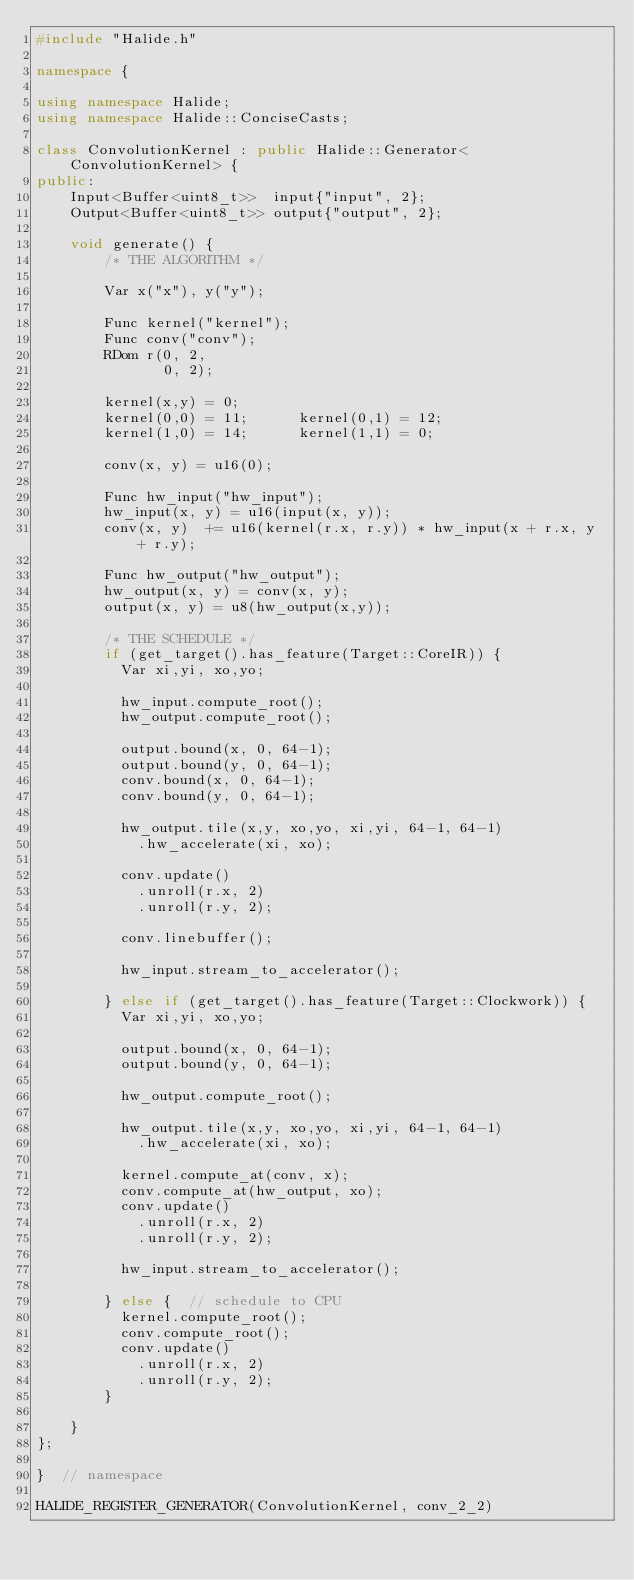<code> <loc_0><loc_0><loc_500><loc_500><_C++_>#include "Halide.h"

namespace {

using namespace Halide;
using namespace Halide::ConciseCasts;

class ConvolutionKernel : public Halide::Generator<ConvolutionKernel> {
public:
    Input<Buffer<uint8_t>>  input{"input", 2};
    Output<Buffer<uint8_t>> output{"output", 2};

    void generate() {
        /* THE ALGORITHM */

        Var x("x"), y("y");

        Func kernel("kernel");
        Func conv("conv");
        RDom r(0, 2,
               0, 2);

        kernel(x,y) = 0;
        kernel(0,0) = 11;      kernel(0,1) = 12;
        kernel(1,0) = 14;      kernel(1,1) = 0;

        conv(x, y) = u16(0);

        Func hw_input("hw_input");
        hw_input(x, y) = u16(input(x, y));
        conv(x, y)  += u16(kernel(r.x, r.y)) * hw_input(x + r.x, y + r.y);

        Func hw_output("hw_output");
        hw_output(x, y) = conv(x, y);
        output(x, y) = u8(hw_output(x,y));

        /* THE SCHEDULE */
        if (get_target().has_feature(Target::CoreIR)) {
          Var xi,yi, xo,yo;

          hw_input.compute_root();
          hw_output.compute_root();

          output.bound(x, 0, 64-1);
          output.bound(y, 0, 64-1);
          conv.bound(x, 0, 64-1);
          conv.bound(y, 0, 64-1);

          hw_output.tile(x,y, xo,yo, xi,yi, 64-1, 64-1)
            .hw_accelerate(xi, xo);

          conv.update()
            .unroll(r.x, 2)
            .unroll(r.y, 2);

          conv.linebuffer();

          hw_input.stream_to_accelerator();

        } else if (get_target().has_feature(Target::Clockwork)) {
          Var xi,yi, xo,yo;

          output.bound(x, 0, 64-1);
          output.bound(y, 0, 64-1);

          hw_output.compute_root();

          hw_output.tile(x,y, xo,yo, xi,yi, 64-1, 64-1)
            .hw_accelerate(xi, xo);

          kernel.compute_at(conv, x);
          conv.compute_at(hw_output, xo);
          conv.update()
            .unroll(r.x, 2)
            .unroll(r.y, 2);

          hw_input.stream_to_accelerator();

        } else {  // schedule to CPU
          kernel.compute_root();
          conv.compute_root();
          conv.update()
            .unroll(r.x, 2)
            .unroll(r.y, 2);
        }

    }
};

}  // namespace

HALIDE_REGISTER_GENERATOR(ConvolutionKernel, conv_2_2)
</code> 